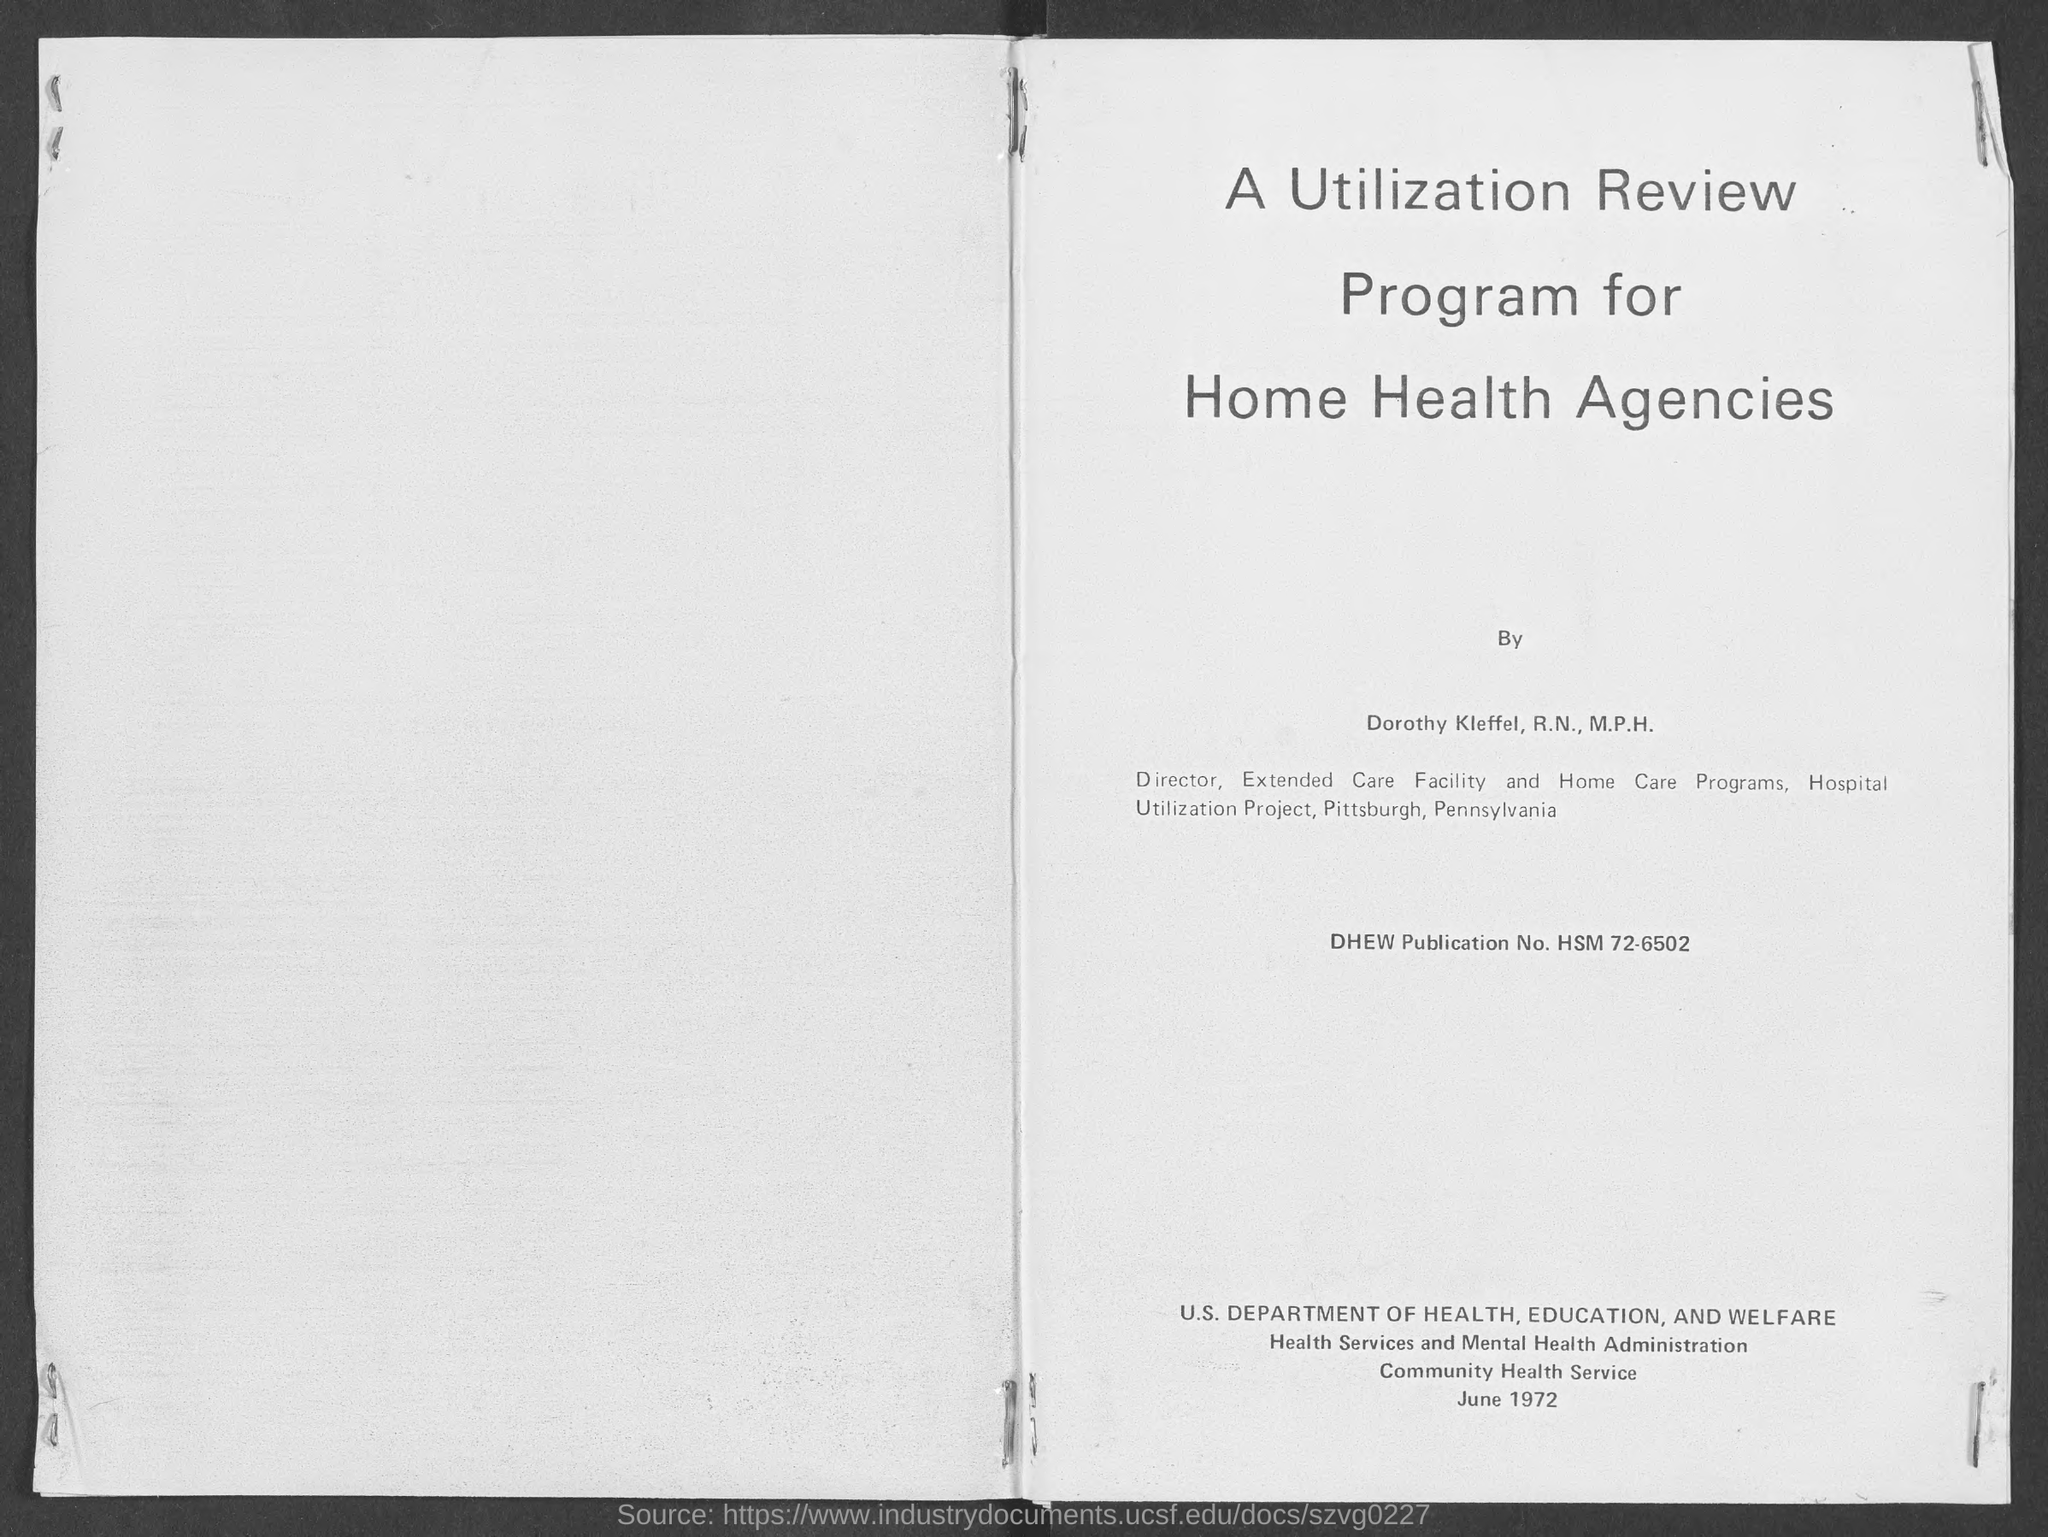What is the DHEW Publication No.?
Provide a succinct answer. HSM 72-6502. 